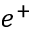<formula> <loc_0><loc_0><loc_500><loc_500>e ^ { + }</formula> 